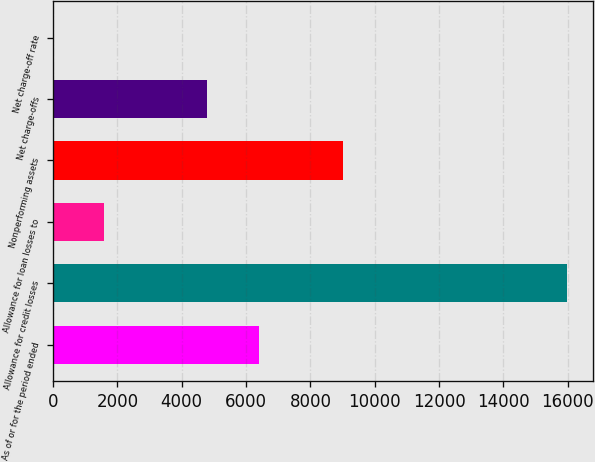<chart> <loc_0><loc_0><loc_500><loc_500><bar_chart><fcel>As of or for the period ended<fcel>Allowance for credit losses<fcel>Allowance for loan losses to<fcel>Nonperforming assets<fcel>Net charge-offs<fcel>Net charge-off rate<nl><fcel>6390<fcel>15974<fcel>1597.98<fcel>9017<fcel>4792.66<fcel>0.64<nl></chart> 